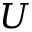<formula> <loc_0><loc_0><loc_500><loc_500>U</formula> 